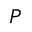<formula> <loc_0><loc_0><loc_500><loc_500>P</formula> 